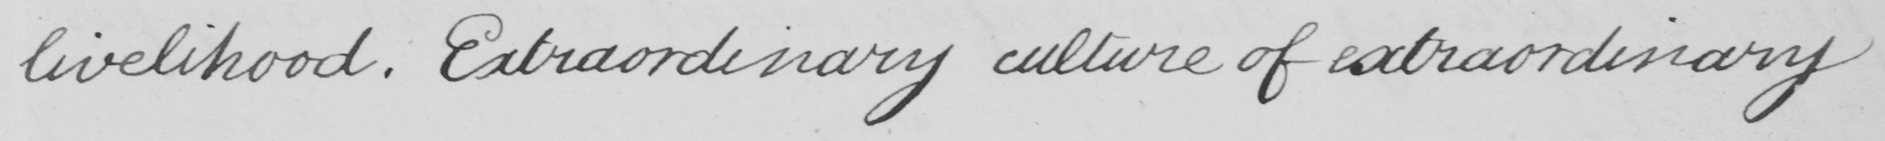Can you read and transcribe this handwriting? livelihood . Extraordinary culture of extraordinary 